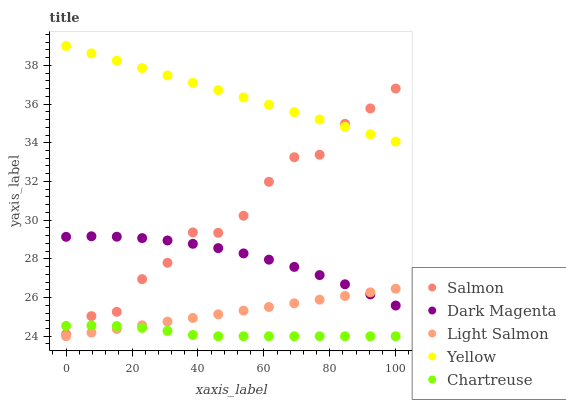Does Chartreuse have the minimum area under the curve?
Answer yes or no. Yes. Does Yellow have the maximum area under the curve?
Answer yes or no. Yes. Does Light Salmon have the minimum area under the curve?
Answer yes or no. No. Does Light Salmon have the maximum area under the curve?
Answer yes or no. No. Is Light Salmon the smoothest?
Answer yes or no. Yes. Is Salmon the roughest?
Answer yes or no. Yes. Is Salmon the smoothest?
Answer yes or no. No. Is Light Salmon the roughest?
Answer yes or no. No. Does Chartreuse have the lowest value?
Answer yes or no. Yes. Does Salmon have the lowest value?
Answer yes or no. No. Does Yellow have the highest value?
Answer yes or no. Yes. Does Light Salmon have the highest value?
Answer yes or no. No. Is Chartreuse less than Yellow?
Answer yes or no. Yes. Is Dark Magenta greater than Chartreuse?
Answer yes or no. Yes. Does Chartreuse intersect Light Salmon?
Answer yes or no. Yes. Is Chartreuse less than Light Salmon?
Answer yes or no. No. Is Chartreuse greater than Light Salmon?
Answer yes or no. No. Does Chartreuse intersect Yellow?
Answer yes or no. No. 